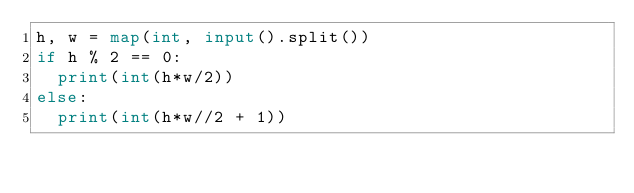<code> <loc_0><loc_0><loc_500><loc_500><_Python_>h, w = map(int, input().split())
if h % 2 == 0:
  print(int(h*w/2))
else:        
  print(int(h*w//2 + 1))
</code> 